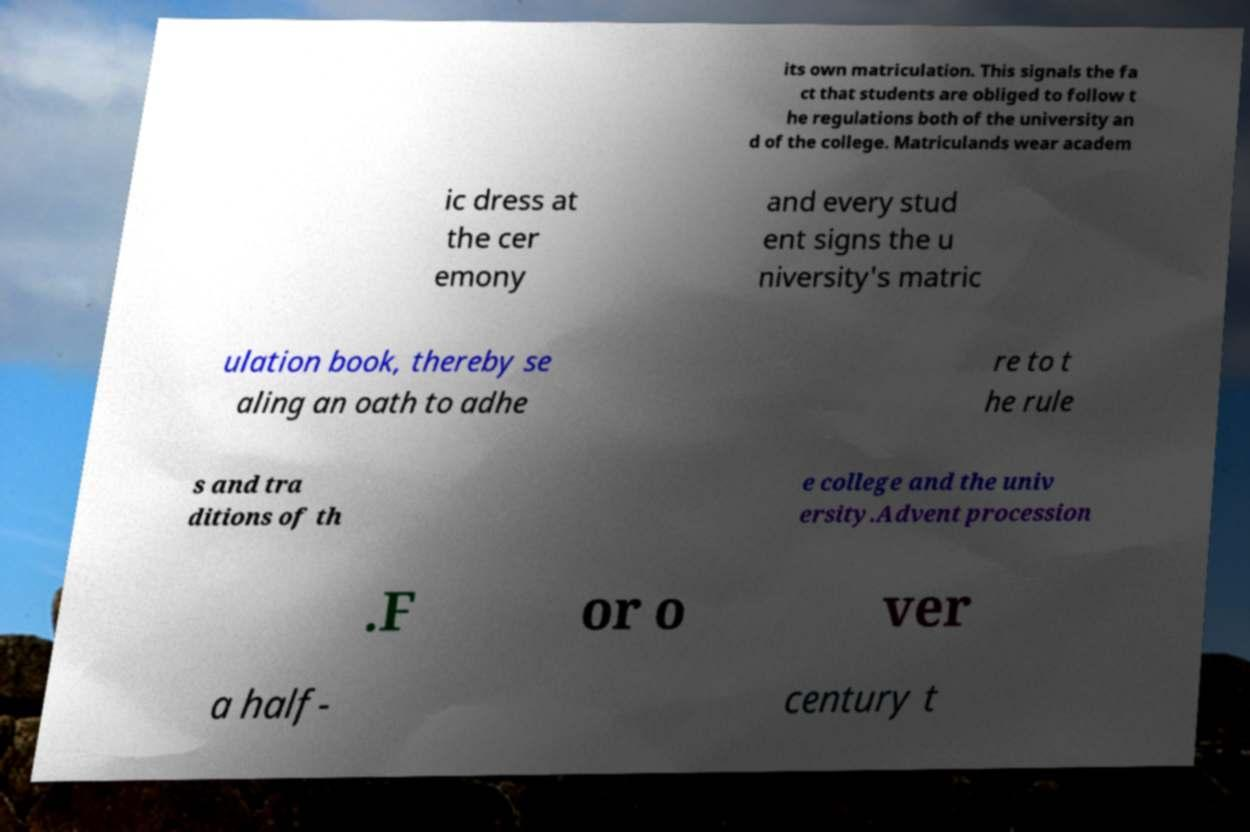Please identify and transcribe the text found in this image. its own matriculation. This signals the fa ct that students are obliged to follow t he regulations both of the university an d of the college. Matriculands wear academ ic dress at the cer emony and every stud ent signs the u niversity's matric ulation book, thereby se aling an oath to adhe re to t he rule s and tra ditions of th e college and the univ ersity.Advent procession .F or o ver a half- century t 